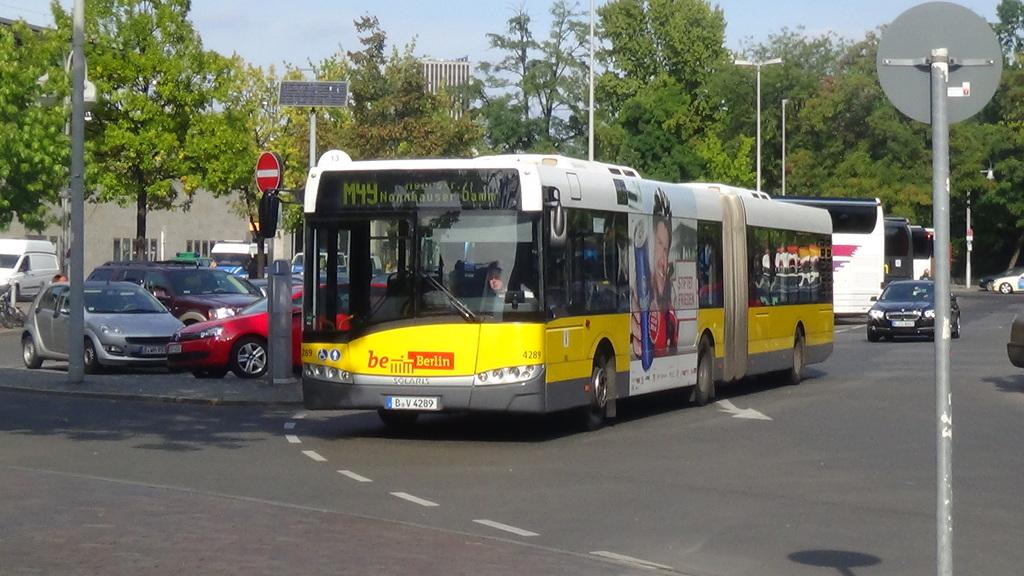What types of vehicles are on the road in the image? There are buses and cars on the road in the image. What can be seen in the background of the image? There are trees visible in the background of the image. What is visible at the top of the image? The sky is visible in the image. What type of milk is being served in the image? There is no milk present in the image; it features buses, cars, trees, and the sky. Can you see a cap on anyone's head in the image? There is no cap visible on anyone's head in the image. 